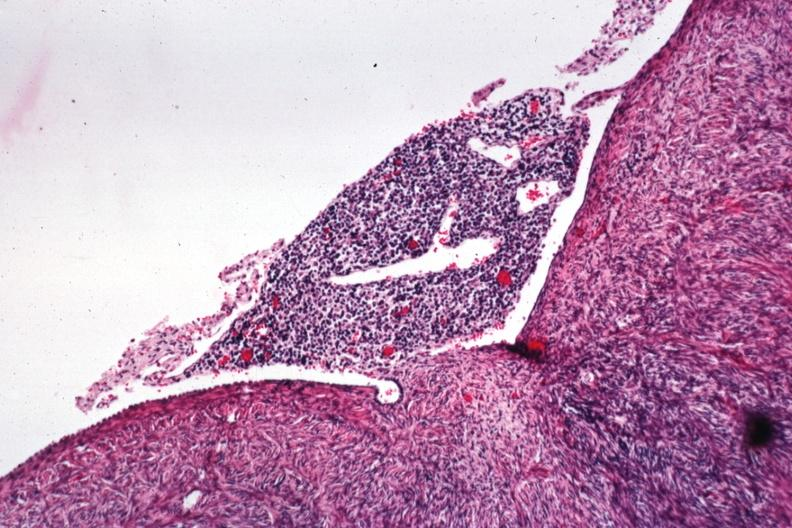s natural color present?
Answer the question using a single word or phrase. No 